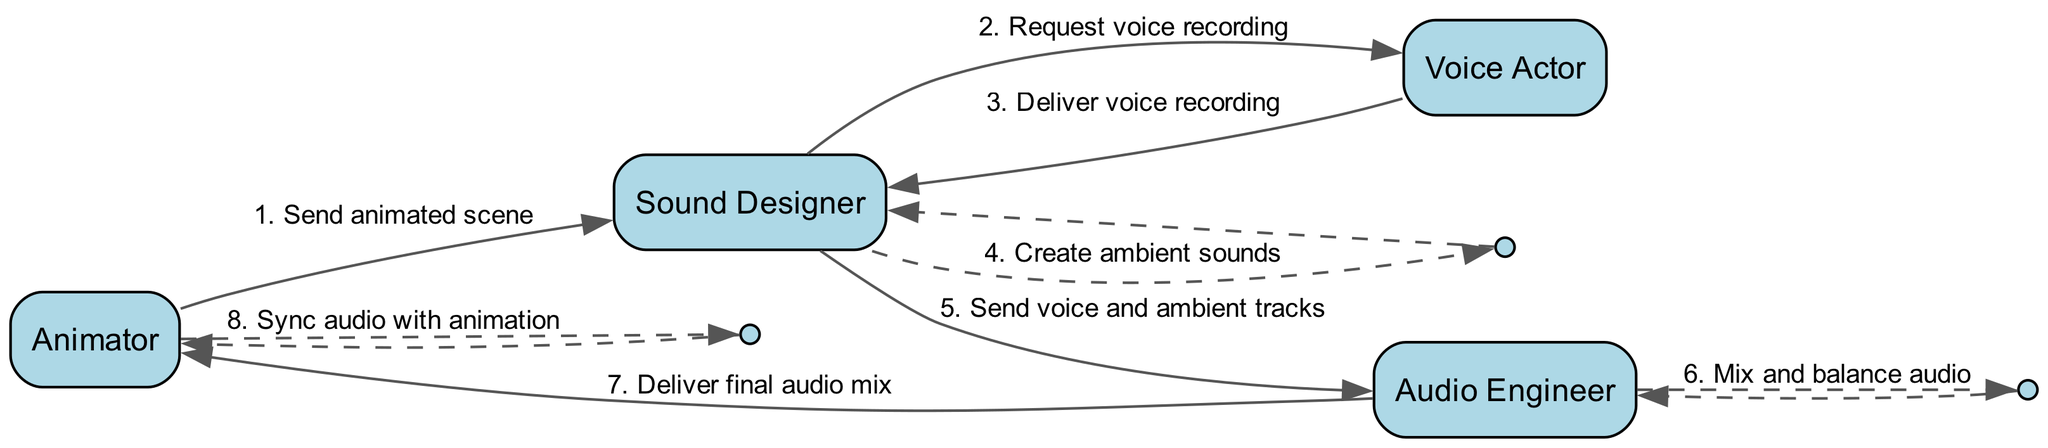What is the first step in the audio mixing process? The first step involves the Animator sending the animated scene to the Sound Designer. This is represented as the first edge in the sequence diagram.
Answer: Send animated scene Who delivers the voice recording? The Voice Actor is the one who delivers the voice recording back to the Sound Designer. This is indicated in the diagram by the edge connecting the Voice Actor to the Sound Designer.
Answer: Deliver voice recording How many actors are involved in the process? There are four actors represented in the diagram: Animator, Sound Designer, Voice Actor, and Audio Engineer. This count comes from identifying each unique node in the diagram.
Answer: Four Which actor creates ambient sounds? The Sound Designer is responsible for creating ambient sounds, as shown in the diagram where there's a self-loop for the Sound Designer with the corresponding message.
Answer: Sound Designer What message is sent from the Audio Engineer to the Animator? The message sent from the Audio Engineer to the Animator is "Deliver final audio mix," which is clearly labeled on the edge from Audio Engineer to Animator in the diagram.
Answer: Deliver final audio mix How many steps involve the Sound Designer? The Sound Designer is involved in three steps: requesting voice recording, creating ambient sounds, and sending voice and ambient tracks. By counting the edges associated with the Sound Designer in the sequence, we find this.
Answer: Three What type of action does the Animator perform at the end of the sequence? At the end of the sequence, the Animator performs the action of syncing audio with animation, as indicated by the self-loop for the Animator at the last step.
Answer: Sync audio with animation What happens after the Audio Engineer mixes and balances audio? After mixing and balancing audio, the Audio Engineer delivers the final audio mix to the Animator, as indicated by the edge from Audio Engineer to Animator.
Answer: Deliver final audio mix 